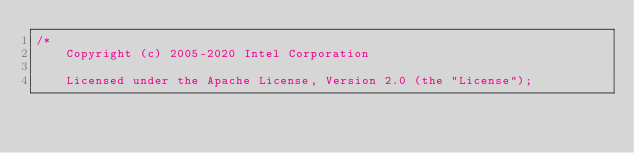Convert code to text. <code><loc_0><loc_0><loc_500><loc_500><_C++_>/*
    Copyright (c) 2005-2020 Intel Corporation

    Licensed under the Apache License, Version 2.0 (the "License");</code> 